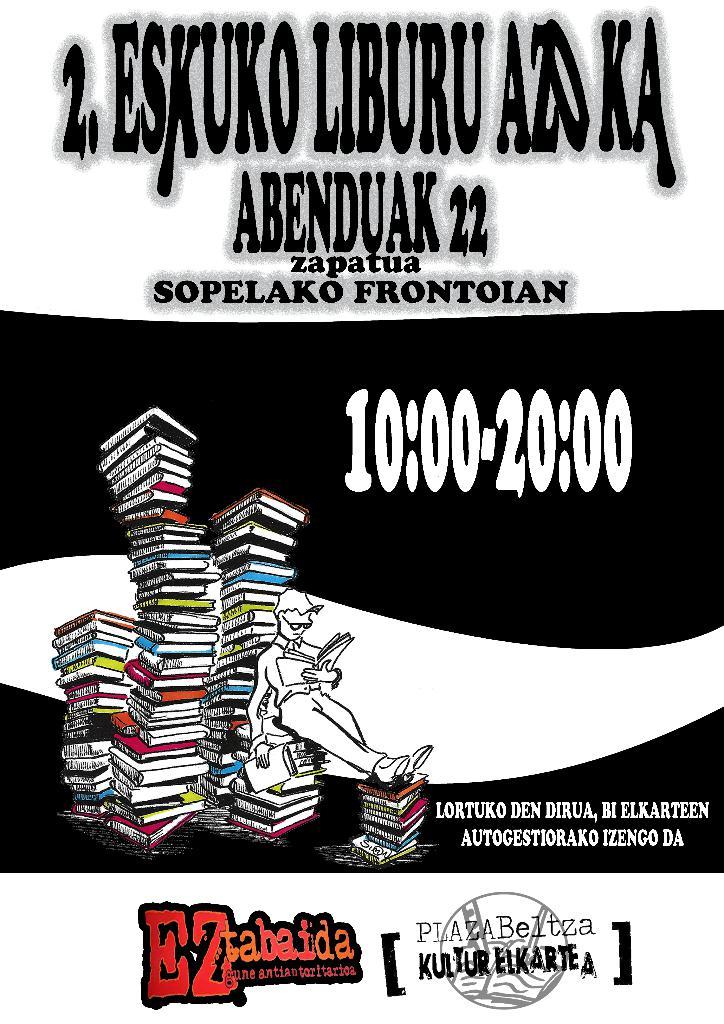What is the title of the event?
Give a very brief answer. Eskuko liburu azoka. 